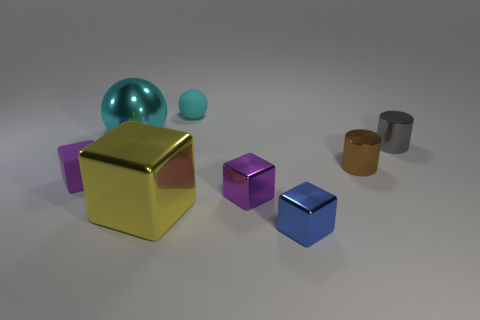There is a purple thing that is behind the purple metallic thing; is it the same size as the cyan rubber thing behind the small brown metallic cylinder?
Provide a short and direct response. Yes. How many tiny purple rubber cubes are there?
Ensure brevity in your answer.  1. What number of large yellow things are made of the same material as the large cyan sphere?
Give a very brief answer. 1. Are there an equal number of large cyan metallic objects that are in front of the yellow shiny block and tiny cyan rubber objects?
Your response must be concise. No. What is the material of the thing that is the same color as the small matte sphere?
Offer a very short reply. Metal. There is a blue shiny object; does it have the same size as the shiny block that is left of the cyan rubber sphere?
Offer a very short reply. No. What number of other things are the same size as the blue metal object?
Your answer should be very brief. 5. What number of other objects are the same color as the big shiny block?
Ensure brevity in your answer.  0. What number of other objects are there of the same shape as the small blue object?
Provide a short and direct response. 3. Do the brown cylinder and the gray shiny object have the same size?
Give a very brief answer. Yes. 